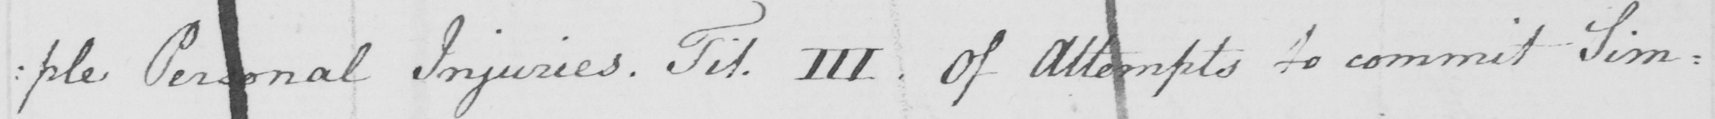What does this handwritten line say? : ple Personal Injuries . Tit . III  . Of attempts to commit Sim= 